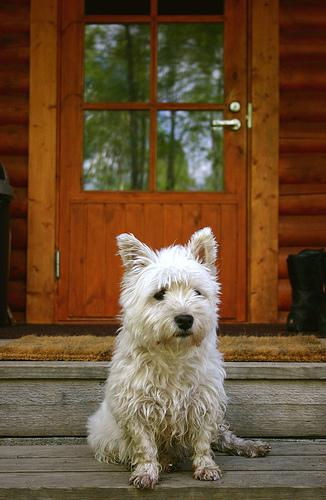Question: what is in the photo?
Choices:
A. A cat.
B. A dog.
C. A fox.
D. A raccoon.
Answer with the letter. Answer: B Question: when was the picture taken of the dog?
Choices:
A. Afternoon.
B. Night time.
C. Daytime.
D. Morning.
Answer with the letter. Answer: C Question: what is on the porch behind the dog?
Choices:
A. A rug.
B. A box.
C. A chair.
D. A potted plant.
Answer with the letter. Answer: A 